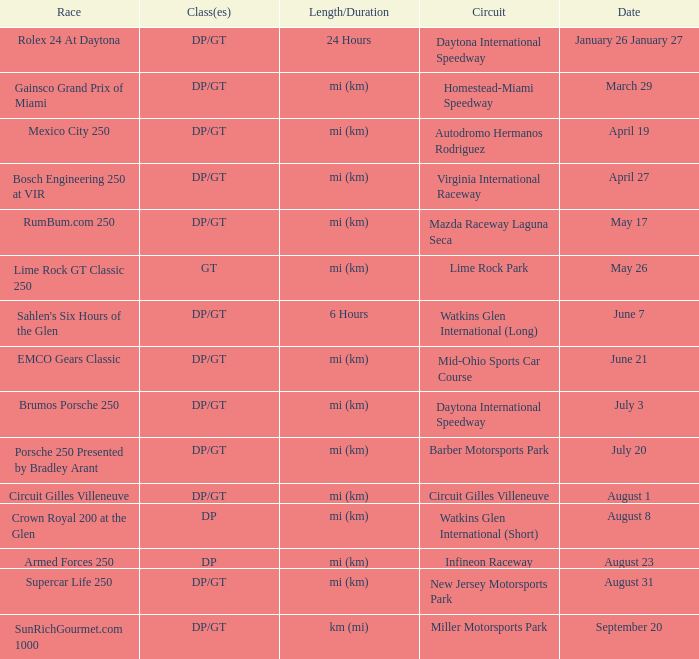What are the classes for the circuit that has the Mazda Raceway Laguna Seca race. DP/GT. 